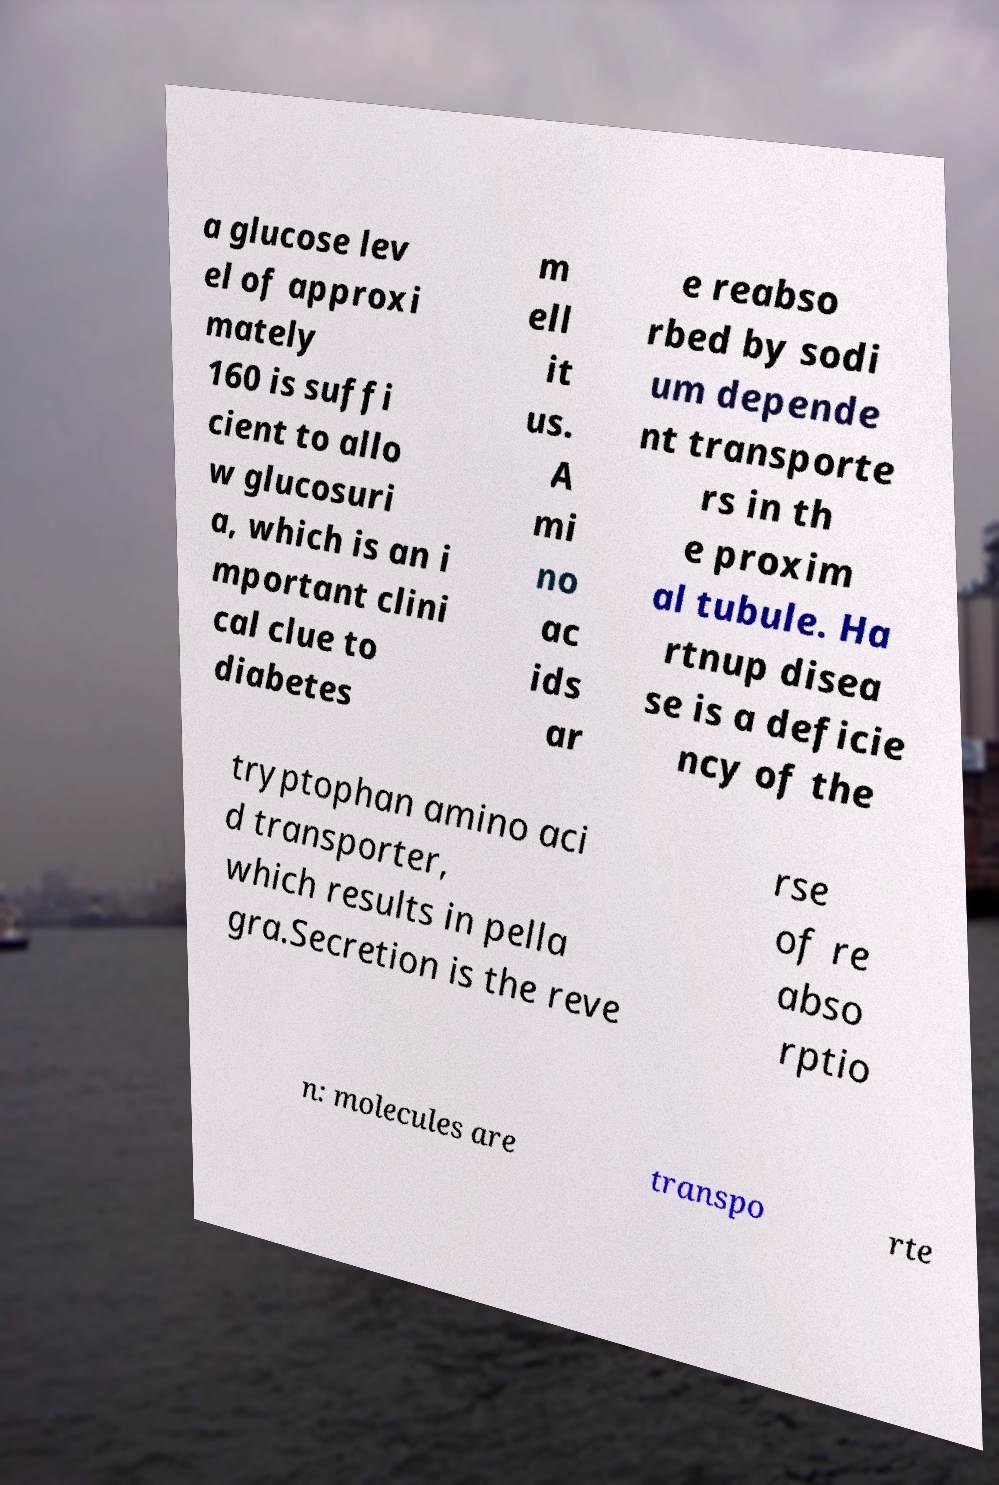Can you read and provide the text displayed in the image?This photo seems to have some interesting text. Can you extract and type it out for me? a glucose lev el of approxi mately 160 is suffi cient to allo w glucosuri a, which is an i mportant clini cal clue to diabetes m ell it us. A mi no ac ids ar e reabso rbed by sodi um depende nt transporte rs in th e proxim al tubule. Ha rtnup disea se is a deficie ncy of the tryptophan amino aci d transporter, which results in pella gra.Secretion is the reve rse of re abso rptio n: molecules are transpo rte 